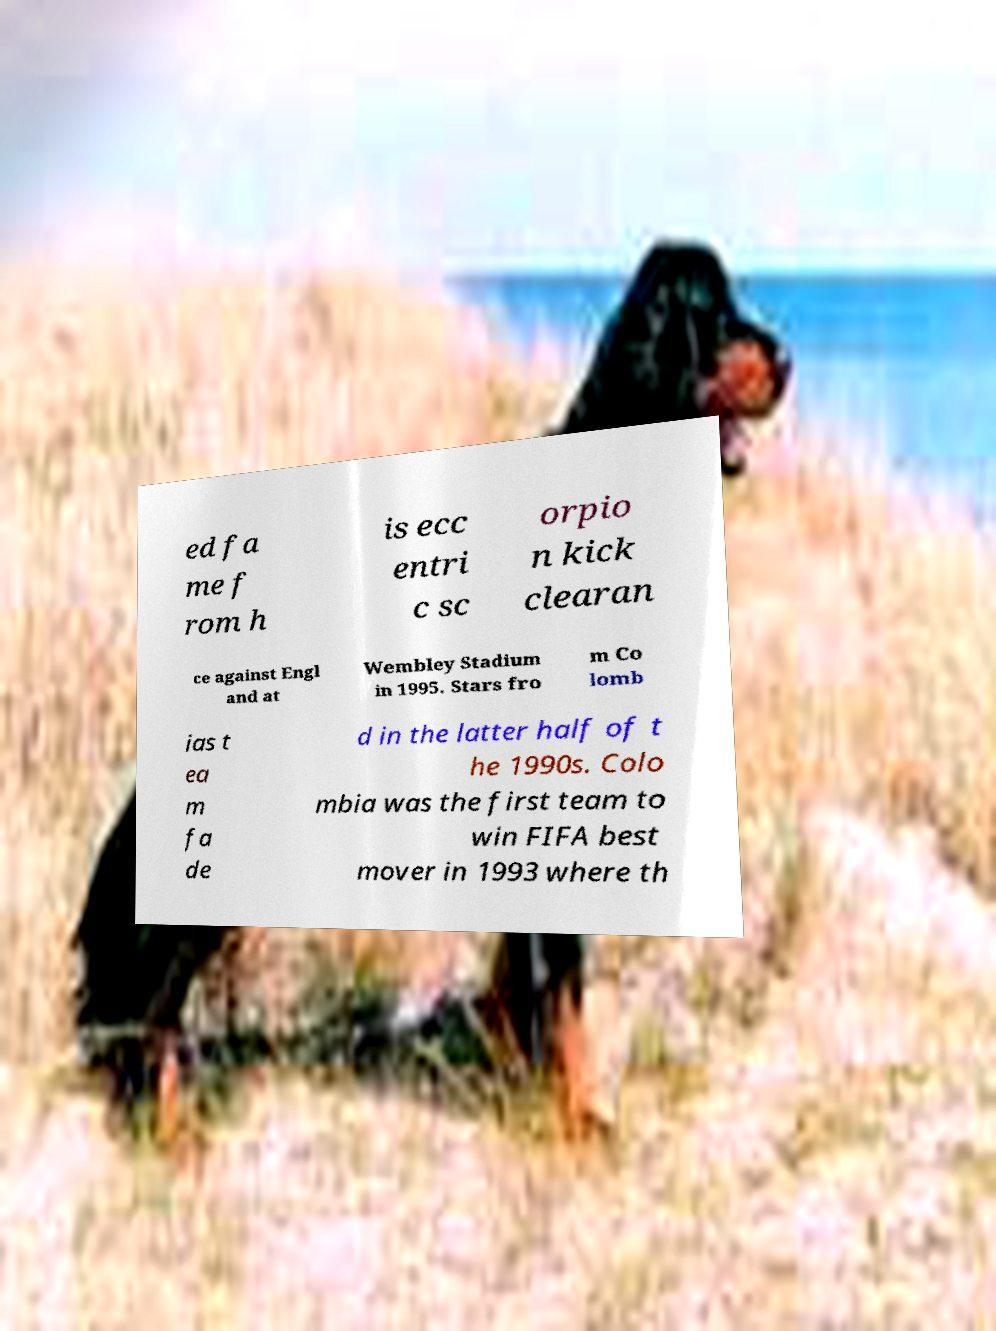What messages or text are displayed in this image? I need them in a readable, typed format. ed fa me f rom h is ecc entri c sc orpio n kick clearan ce against Engl and at Wembley Stadium in 1995. Stars fro m Co lomb ias t ea m fa de d in the latter half of t he 1990s. Colo mbia was the first team to win FIFA best mover in 1993 where th 